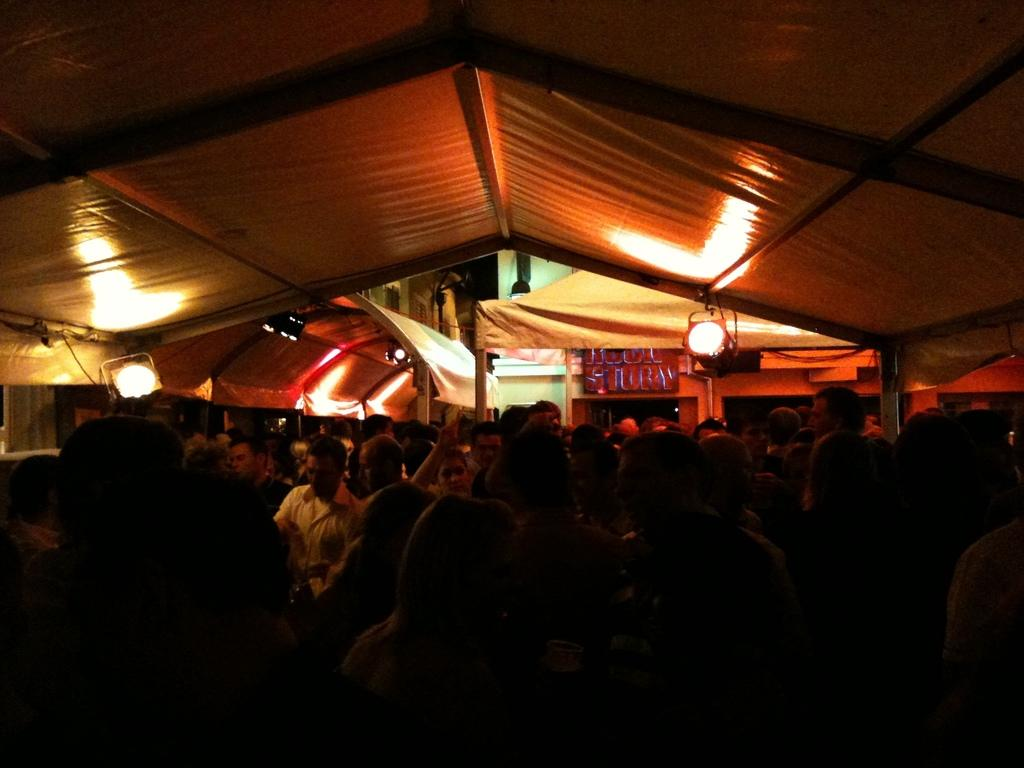How many people are in the image? There are persons in the image, but the exact number is not specified. What are the people in the image doing? Some of the persons are sitting, and some are standing. What can be seen in the background of the image? There are white tents in the background of the image. What else is visible in the image? There are lights visible in the image. What type of sponge is being used by the mother in the image? There is no mention of a mother or a sponge in the image, so this question cannot be answered. 